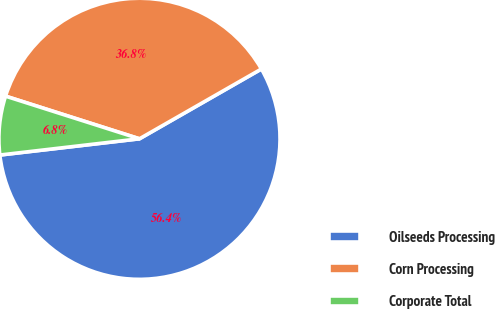Convert chart to OTSL. <chart><loc_0><loc_0><loc_500><loc_500><pie_chart><fcel>Oilseeds Processing<fcel>Corn Processing<fcel>Corporate Total<nl><fcel>56.43%<fcel>36.82%<fcel>6.75%<nl></chart> 